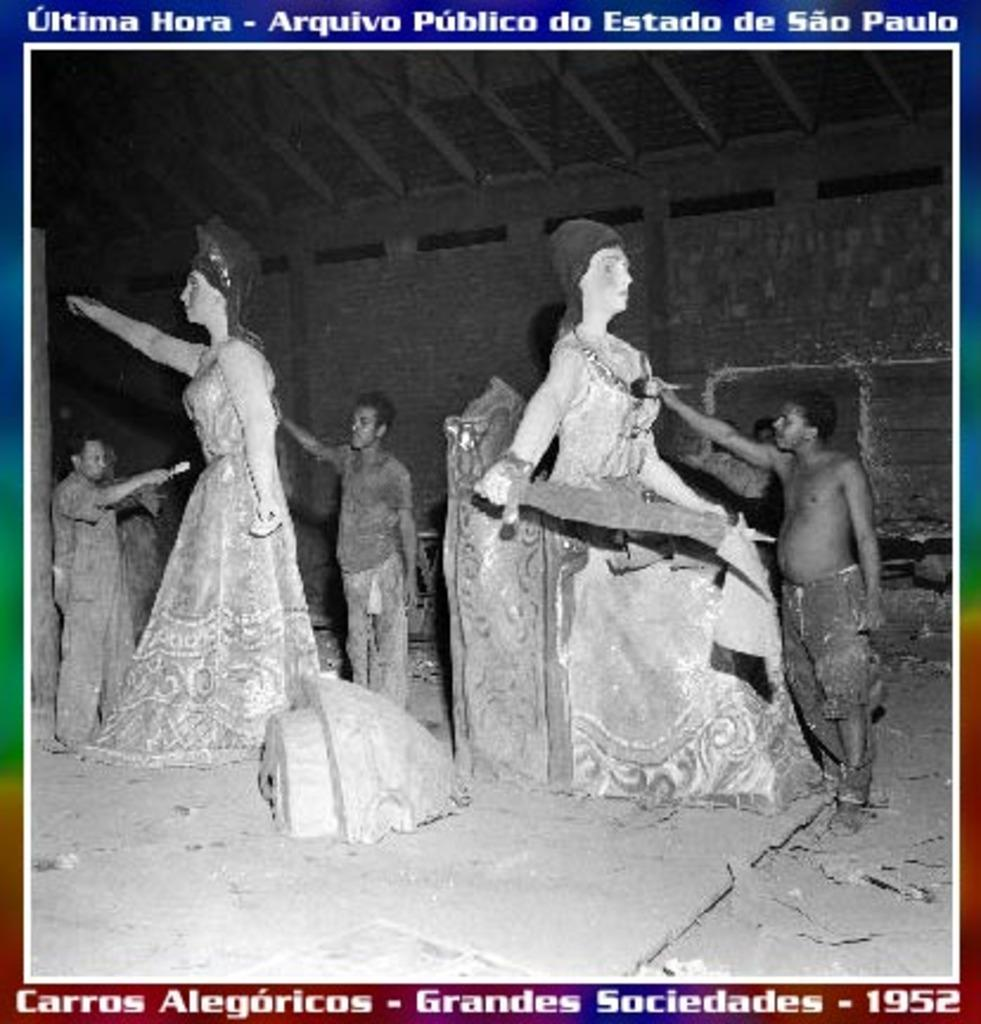Provide a one-sentence caption for the provided image. 1952 stamp showing black men painting white female statues. 